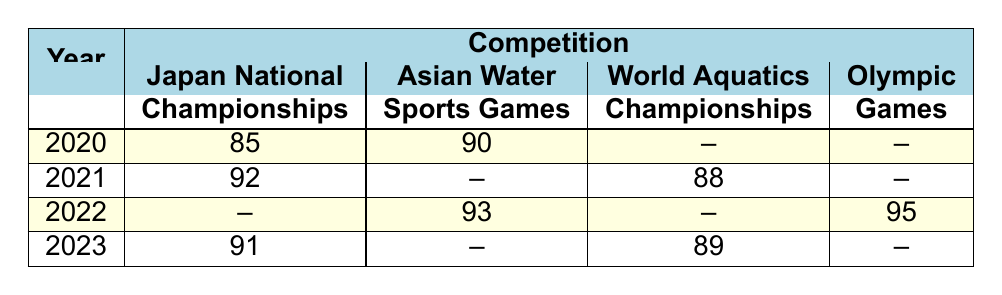What was Akari Inaba's performance rating at the Japan National Championships in 2022? The table indicates that for 2022, the performance rating for Japan National Championships is listed as "--", meaning she did not compete in that event, thus no performance rating is available.
Answer: No performance rating What was the highest performance rating Akari Inaba achieved in 2022? According to the table, the highest rating in 2022 is at the Olympic Games with a performance rating of 95.
Answer: 95 Did Akari Inaba compete in the Asian Water Sports Games in 2021? The table shows that there is no entry for Akari Inaba in the Asian Water Sports Games for 2021; it is marked as "--".
Answer: No What is the average performance rating of Akari Inaba across all competitions in 2020? For 2020, there are two performance ratings: 85 (Japan National Championships) and 90 (Asian Water Sports Games). The average is (85 + 90) / 2 = 87.5.
Answer: 87.5 In which year did Akari Inaba achieve the lowest performance rating among all competitions? By checking all the performance ratings, 85 in 2020 (Japan National Championships) is the lowest rating compared to all other ratings in other years.
Answer: 2020 What was the difference in performance rating between the Asian Water Sports Games in 2020 and 2022? In 2020, the rating was 90, and in 2022 it was 93 for the same competition. The difference is 93 - 90 = 3.
Answer: 3 Which competition had the highest rating for Akari Inaba in 2021? In 2021, the performances were 92 (Japan National Championships) and 88 (World Aquatics Championships). The highest is 92.
Answer: Japan National Championships Was Akari Inaba's performance rating consistent across all competitions? Checking the performance ratings shows that they varied by year and competition, meaning her ratings were not consistent.
Answer: No What were the total competitions Akari Inaba participated in from 2020 to 2023? Adding the competitions over the four years: 2 (2020) + 2 (2021) + 2 (2022) + 2 (2023) = 8 competitions in total.
Answer: 8 competitions 